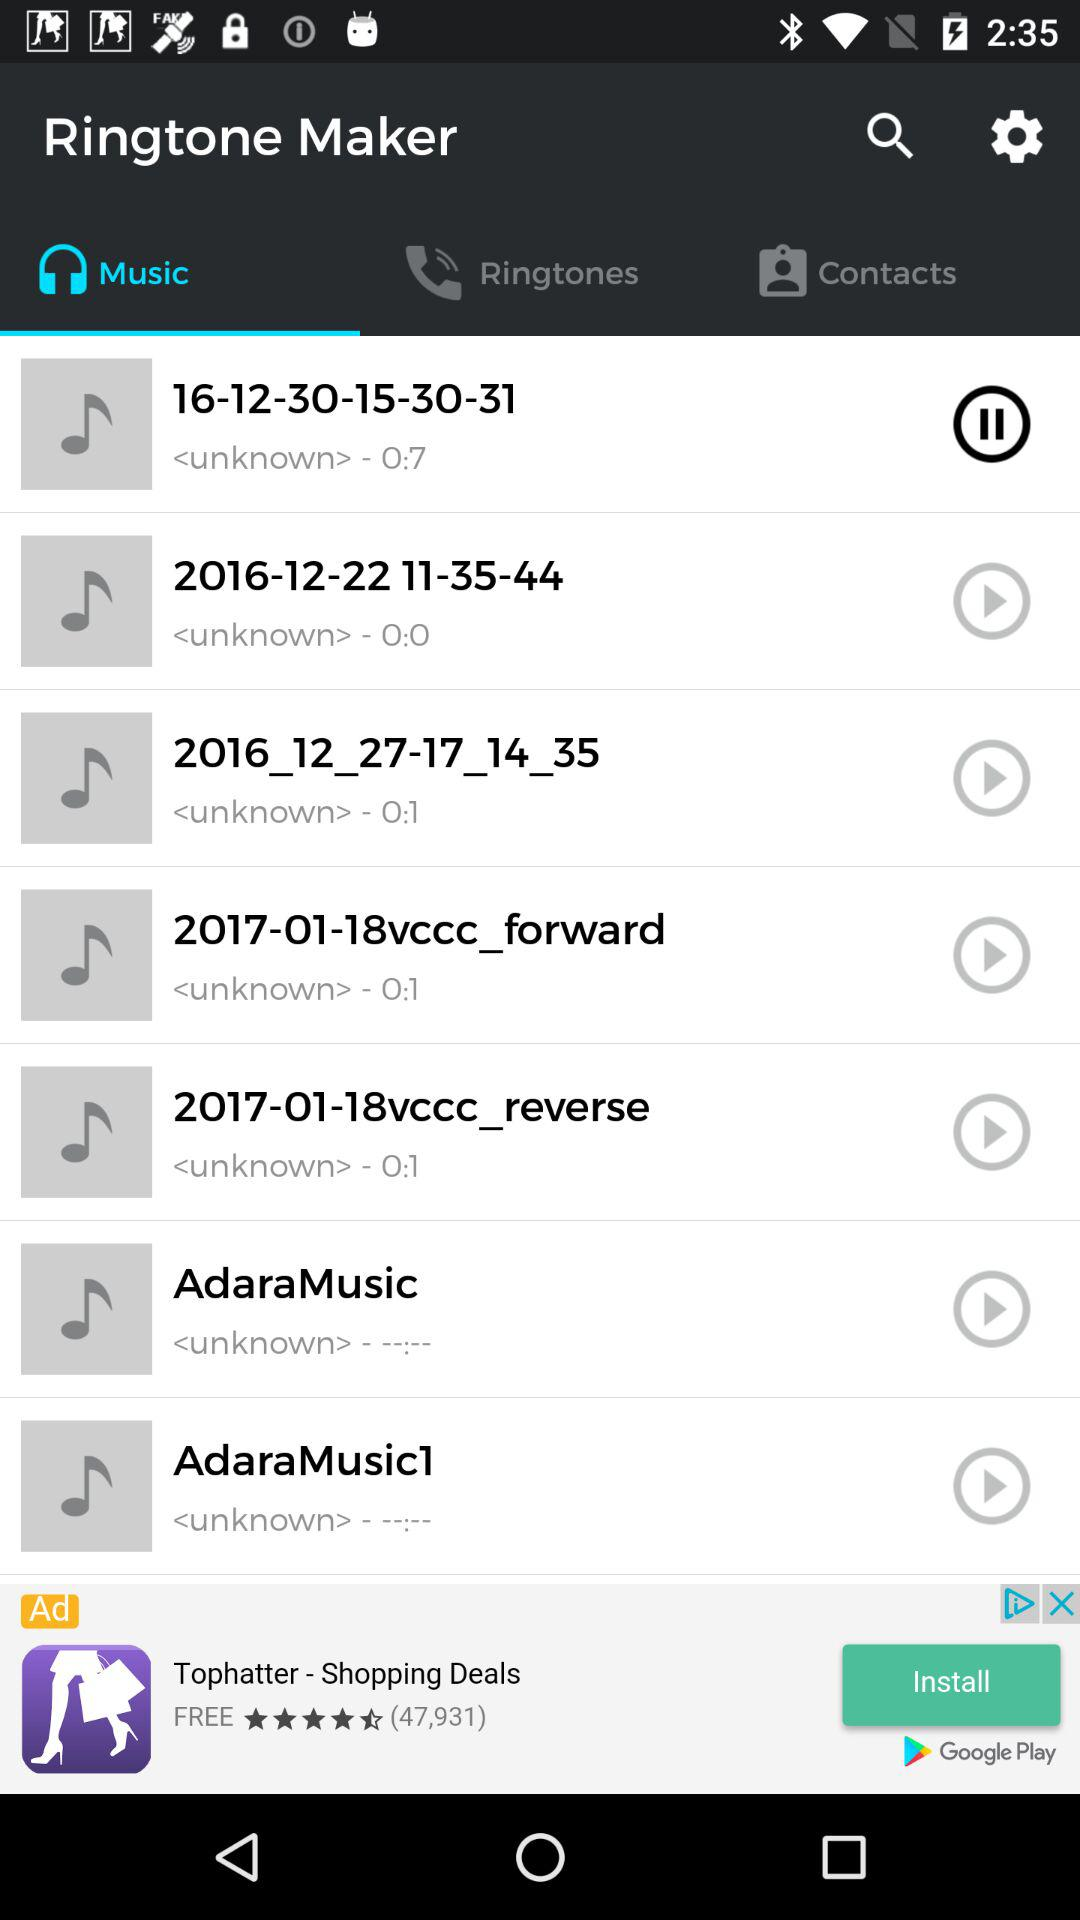What is the name of the application? The name of the application is "Ringtone Maker". 